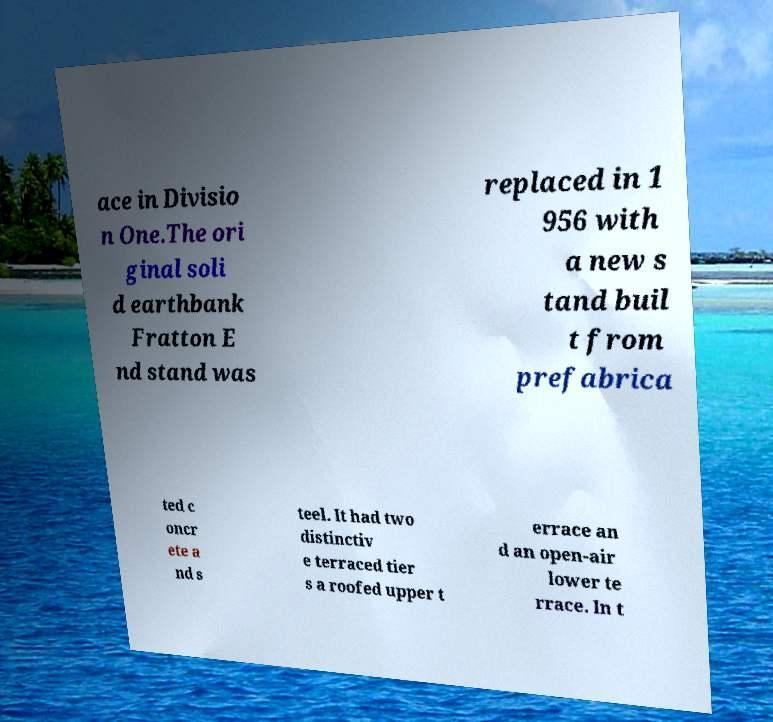Please read and relay the text visible in this image. What does it say? ace in Divisio n One.The ori ginal soli d earthbank Fratton E nd stand was replaced in 1 956 with a new s tand buil t from prefabrica ted c oncr ete a nd s teel. It had two distinctiv e terraced tier s a roofed upper t errace an d an open-air lower te rrace. In t 